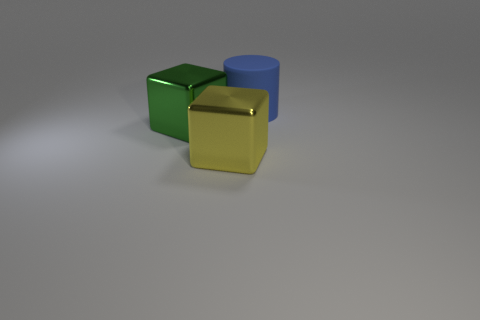Add 3 green metallic blocks. How many objects exist? 6 Subtract all cubes. How many objects are left? 1 Subtract all blue cylinders. Subtract all blue matte objects. How many objects are left? 1 Add 3 blocks. How many blocks are left? 5 Add 1 large blue matte cylinders. How many large blue matte cylinders exist? 2 Subtract 0 purple cubes. How many objects are left? 3 